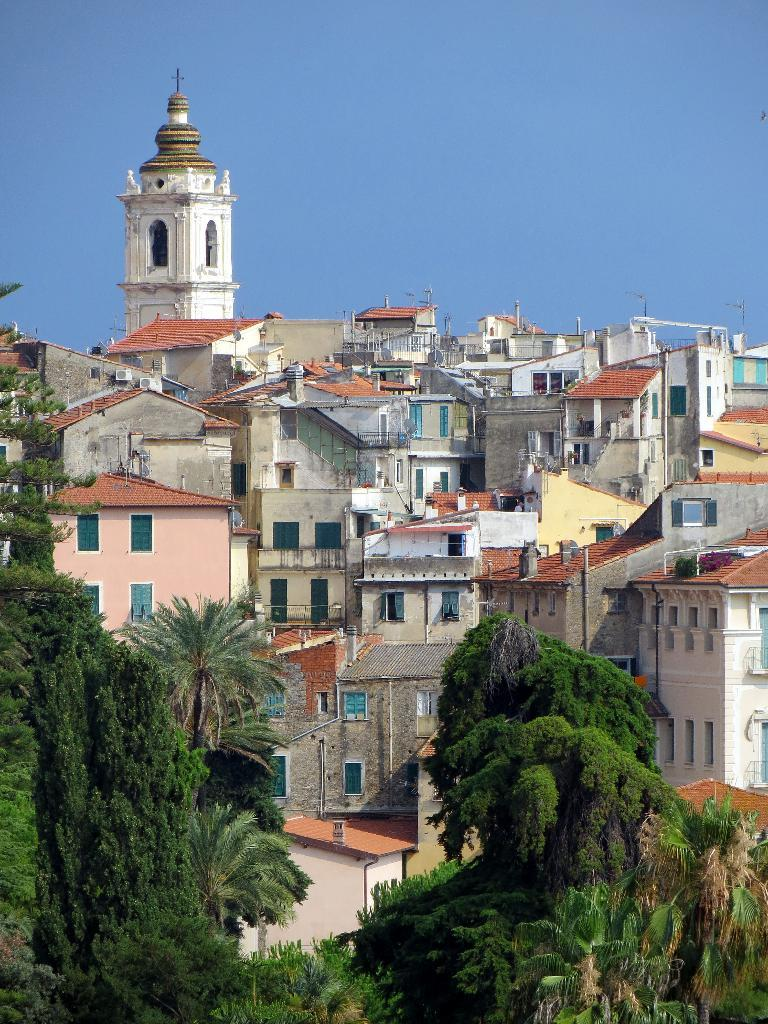What type of view is shown in the image? The image is an outside view. What can be seen at the bottom of the image? There are many trees at the bottom of the image. What is visible in the background of the image? There are many buildings in the background of the image. What is visible at the top of the image? The sky is visible at the top of the image. Where is the band playing in the image? There is no band present in the image. How many sheep can be seen grazing in the image? There are no sheep present in the image. 